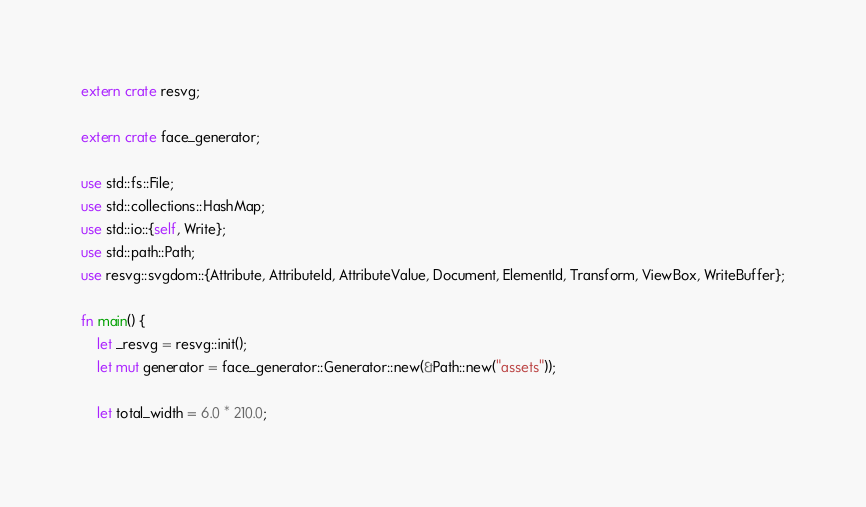Convert code to text. <code><loc_0><loc_0><loc_500><loc_500><_Rust_>extern crate resvg;

extern crate face_generator;

use std::fs::File;
use std::collections::HashMap;
use std::io::{self, Write};
use std::path::Path;
use resvg::svgdom::{Attribute, AttributeId, AttributeValue, Document, ElementId, Transform, ViewBox, WriteBuffer};

fn main() {
    let _resvg = resvg::init();
    let mut generator = face_generator::Generator::new(&Path::new("assets"));

    let total_width = 6.0 * 210.0;</code> 